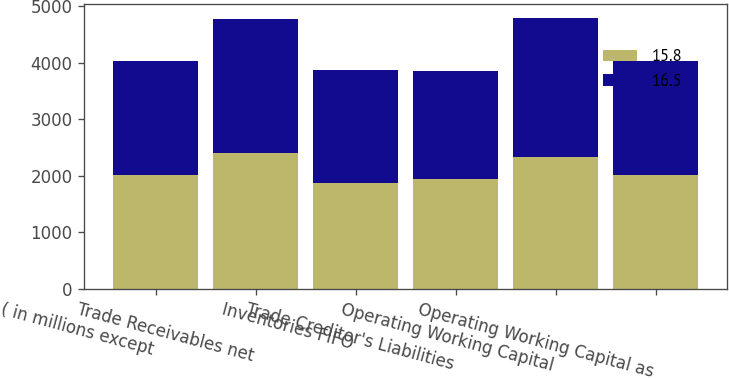Convert chart to OTSL. <chart><loc_0><loc_0><loc_500><loc_500><stacked_bar_chart><ecel><fcel>( in millions except<fcel>Trade Receivables net<fcel>Inventories FIFO<fcel>Trade Creditor's Liabilities<fcel>Operating Working Capital<fcel>Operating Working Capital as<nl><fcel>15.8<fcel>2015<fcel>2413<fcel>1868<fcel>1940<fcel>2341<fcel>2014.5<nl><fcel>16.5<fcel>2014<fcel>2366<fcel>2007<fcel>1919<fcel>2454<fcel>2014.5<nl></chart> 